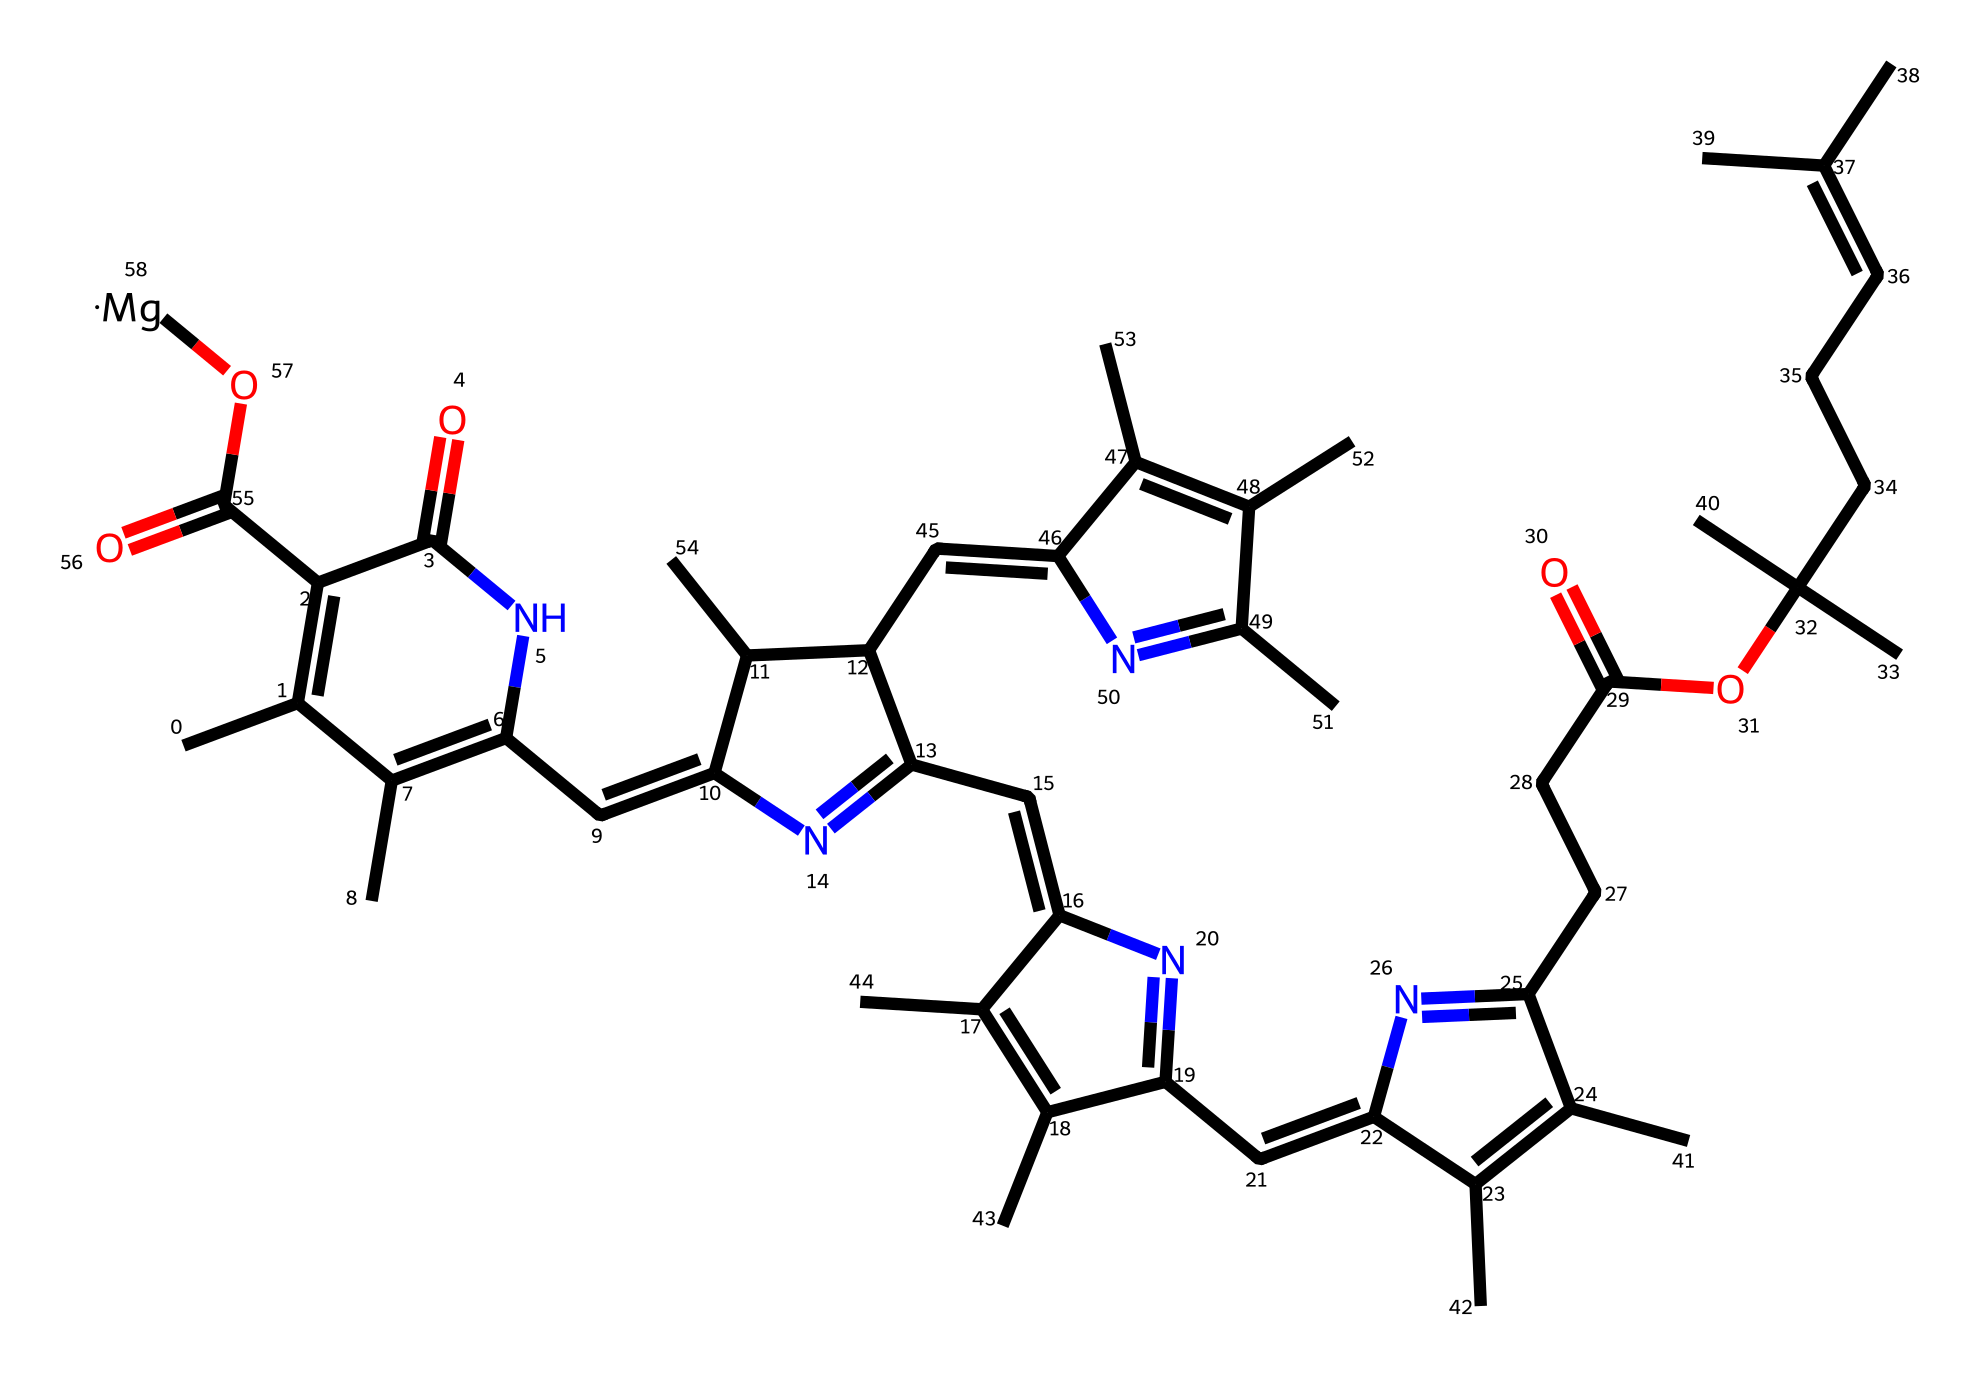What is the molecular formula for chlorophyll? By analyzing the provided SMILES representation, we can identify the types and counts of each atom present in the structure. The counts of carbon (C), hydrogen (H), nitrogen (N), oxygen (O), and magnesium (Mg) provide the molecular formula. The counts yield C55H70N4O6Mg.
Answer: C55H70N4O6Mg How many nitrogen atoms are present in the chlorophyll structure? Inspecting the SMILES string, we can find nitrogen atoms represented by the letter 'N'. Counting these gives us a total of four nitrogen atoms in the molecule.
Answer: 4 What type of compound is chlorophyll classified as? Chlorophyll possesses a structure with alternating double bonds and a stable benzene-like ring, characteristic of aromatic compounds. This classifies chlorophyll primarily as an aromatic compound.
Answer: aromatic What functional groups are present in chlorophyll? By examining the SMILES string and identifying groups like the carboxylic acid (–COOH) and amide (–C(=O)N–), we conclude that chlorophyll contains both a carboxylic acid and amide functional groups.
Answer: carboxylic acid and amide What is the role of magnesium in chlorophyll? Magnesium ions (Mg) are crucial for the structure of chlorophyll, as they are located in the center of the porphyrin ring and are essential for its function in photosynthesis, assisting in the absorption of light.
Answer: central ion for photosynthesis What is the significance of the double bonds in chlorophyll? The presence of double bonds within the structure contributes to the conjugated system, allowing chlorophyll to absorb light efficiently. This conjugation is essential for its role in photosynthesis.
Answer: light absorption In what part of the plant is chlorophyll predominantly found? Chlorophyll is predominantly located in the chloroplasts of plant cells, which are specialized organelles that facilitate photosynthesis. This is derived from our understanding of plant cell structure and functions.
Answer: chloroplasts 